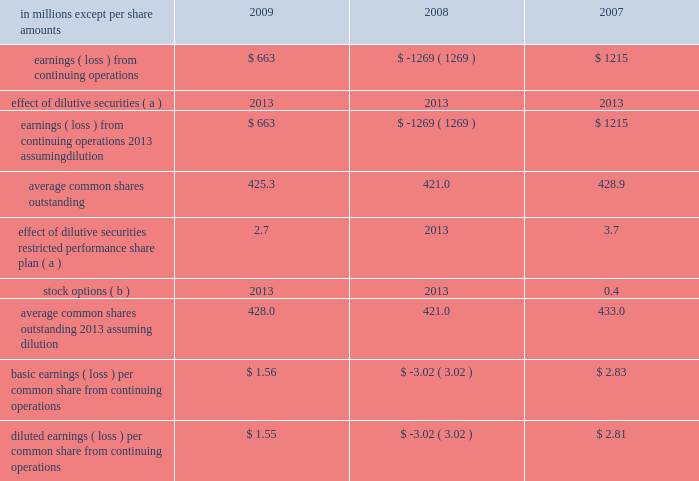In april 2009 , the fasb issued additional guidance under asc 820 which provides guidance on estimat- ing the fair value of an asset or liability ( financial or nonfinancial ) when the volume and level of activity for the asset or liability have significantly decreased , and on identifying transactions that are not orderly .
The application of the requirements of this guidance did not have a material effect on the accompanying consolidated financial statements .
In august 2009 , the fasb issued asu 2009-05 , 201cmeasuring liabilities at fair value , 201d which further amends asc 820 by providing clarification for cir- cumstances in which a quoted price in an active market for the identical liability is not available .
The company included the disclosures required by this guidance in the accompanying consolidated financial statements .
Accounting for uncertainty in income taxes in june 2006 , the fasb issued guidance under asc 740 , 201cincome taxes 201d ( formerly fin 48 ) .
This guid- ance prescribes a recognition threshold and measurement attribute for the financial statement recognition and measurement of a tax position taken or expected to be taken in tax returns .
Specifically , the financial statement effects of a tax position may be recognized only when it is determined that it is 201cmore likely than not 201d that , based on its technical merits , the tax position will be sustained upon examination by the relevant tax authority .
The amount recognized shall be measured as the largest amount of tax benefits that exceed a 50% ( 50 % ) probability of being recognized .
This guidance also expands income tax disclosure requirements .
International paper applied the provisions of this guidance begin- ning in the first quarter of 2007 .
The adoption of this guidance resulted in a charge to the beginning bal- ance of retained earnings of $ 94 million at the date of adoption .
Note 3 industry segment information financial information by industry segment and geo- graphic area for 2009 , 2008 and 2007 is presented on pages 47 and 48 .
Effective january 1 , 2008 , the company changed its method of allocating corpo- rate overhead expenses to its business segments to increase the expense amounts allocated to these businesses in reports reviewed by its chief executive officer to facilitate performance comparisons with other companies .
Accordingly , the company has revised its presentation of industry segment operat- ing profit to reflect this change in allocation method , and has adjusted all comparative prior period information on this basis .
Note 4 earnings per share attributable to international paper company common shareholders basic earnings per common share from continuing operations are computed by dividing earnings from continuing operations by the weighted average number of common shares outstanding .
Diluted earnings per common share from continuing oper- ations are computed assuming that all potentially dilutive securities , including 201cin-the-money 201d stock options , were converted into common shares at the beginning of each year .
In addition , the computation of diluted earnings per share reflects the inclusion of contingently convertible securities in periods when dilutive .
A reconciliation of the amounts included in the computation of basic earnings per common share from continuing operations , and diluted earnings per common share from continuing operations is as fol- in millions except per share amounts 2009 2008 2007 .
Average common shares outstanding 2013 assuming dilution 428.0 421.0 433.0 basic earnings ( loss ) per common share from continuing operations $ 1.56 $ ( 3.02 ) $ 2.83 diluted earnings ( loss ) per common share from continuing operations $ 1.55 $ ( 3.02 ) $ 2.81 ( a ) securities are not included in the table in periods when anti- dilutive .
( b ) options to purchase 22.2 million , 25.1 million and 17.5 million shares for the years ended december 31 , 2009 , 2008 and 2007 , respectively , were not included in the computation of diluted common shares outstanding because their exercise price exceeded the average market price of the company 2019s common stock for each respective reporting date .
Note 5 restructuring and other charges this footnote discusses restructuring and other charges recorded for each of the three years included in the period ended december 31 , 2009 .
It .
What was the net change in diluted earnings ( loss ) per common share from continuing operations between 2007 and 2008? 
Computations: (-3.02 - 2.81)
Answer: -5.83. 